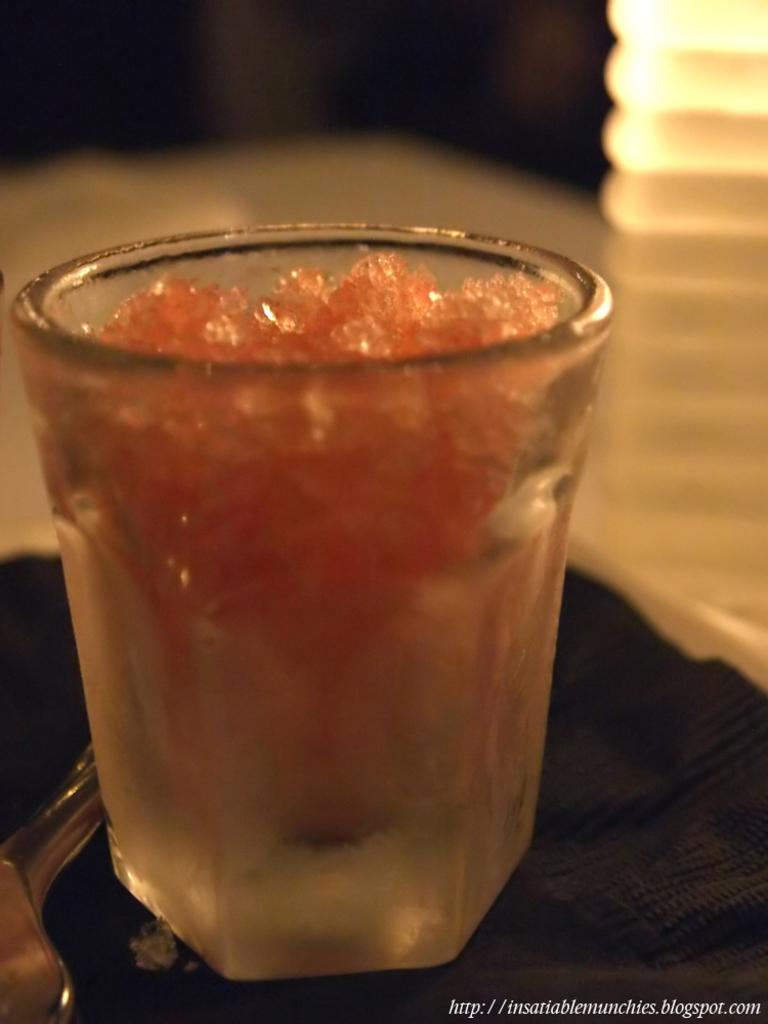What can be seen in the image that is typically used for holding liquids? There is a glass in the image. What is inside the glass? There is an unspecified object or substance in the glass. Can you describe any additional features of the image? There is a watermark at the right bottom of the image. How does the feeling of the air change throughout the image? There is no mention of air or feelings in the image, so it is not possible to answer this question. 